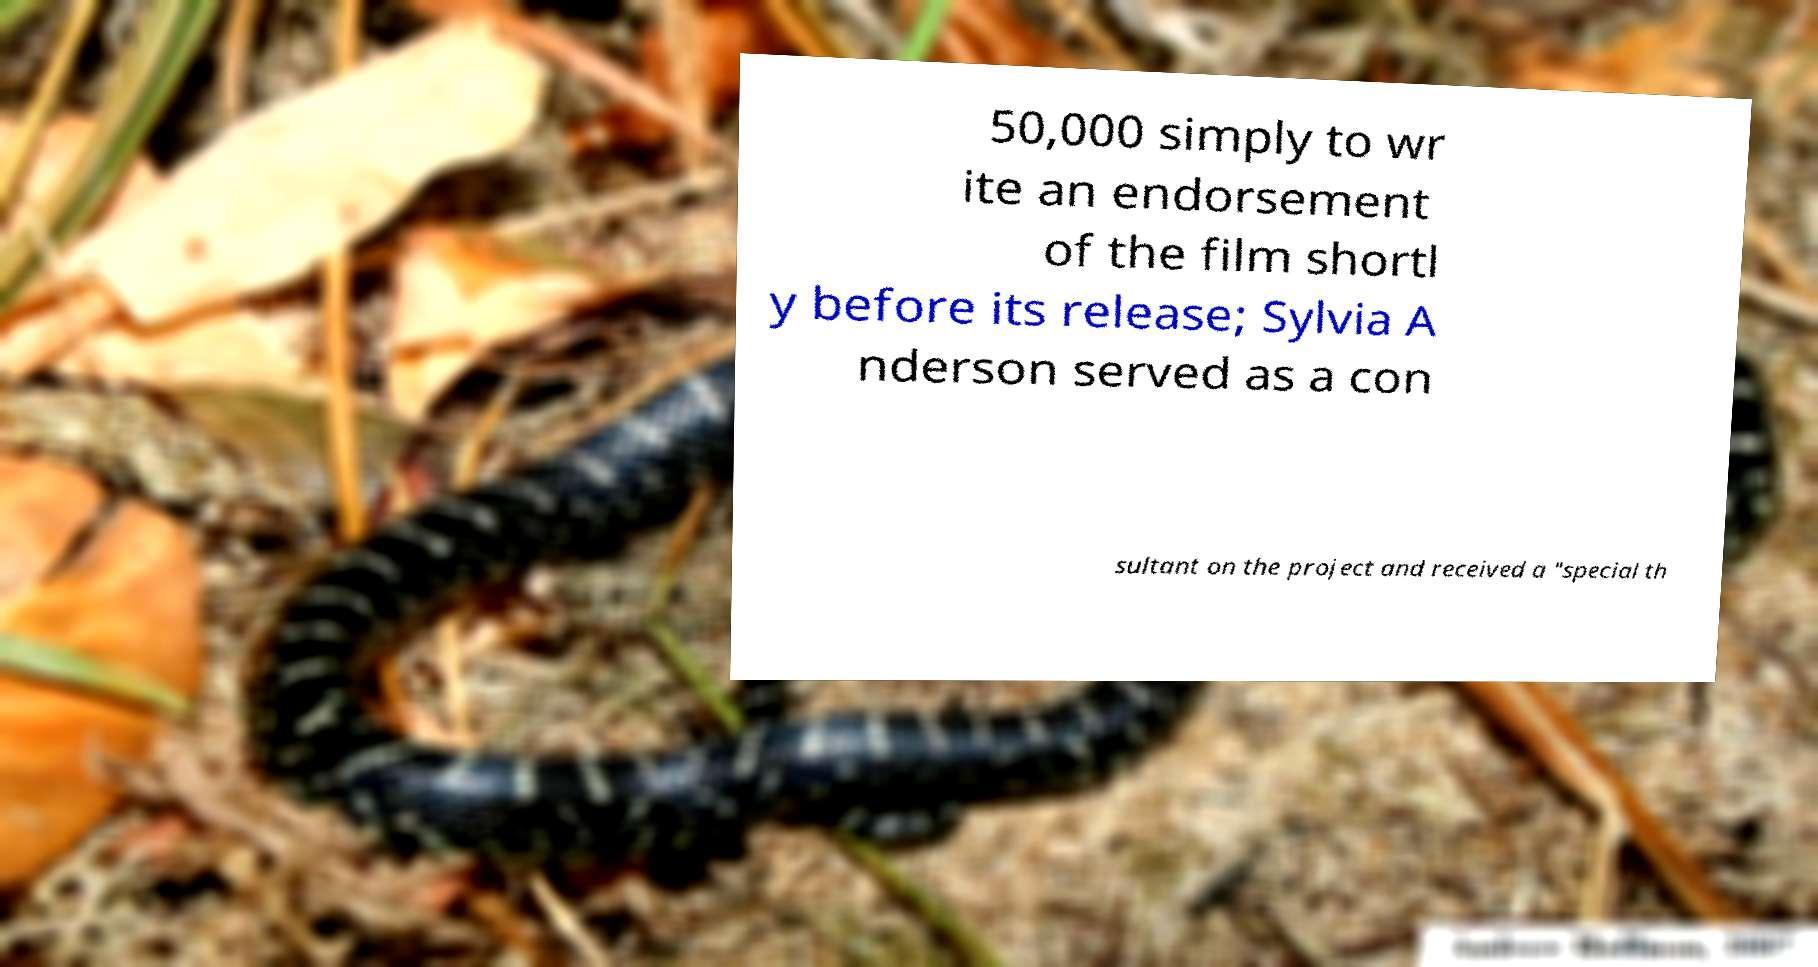What messages or text are displayed in this image? I need them in a readable, typed format. 50,000 simply to wr ite an endorsement of the film shortl y before its release; Sylvia A nderson served as a con sultant on the project and received a "special th 